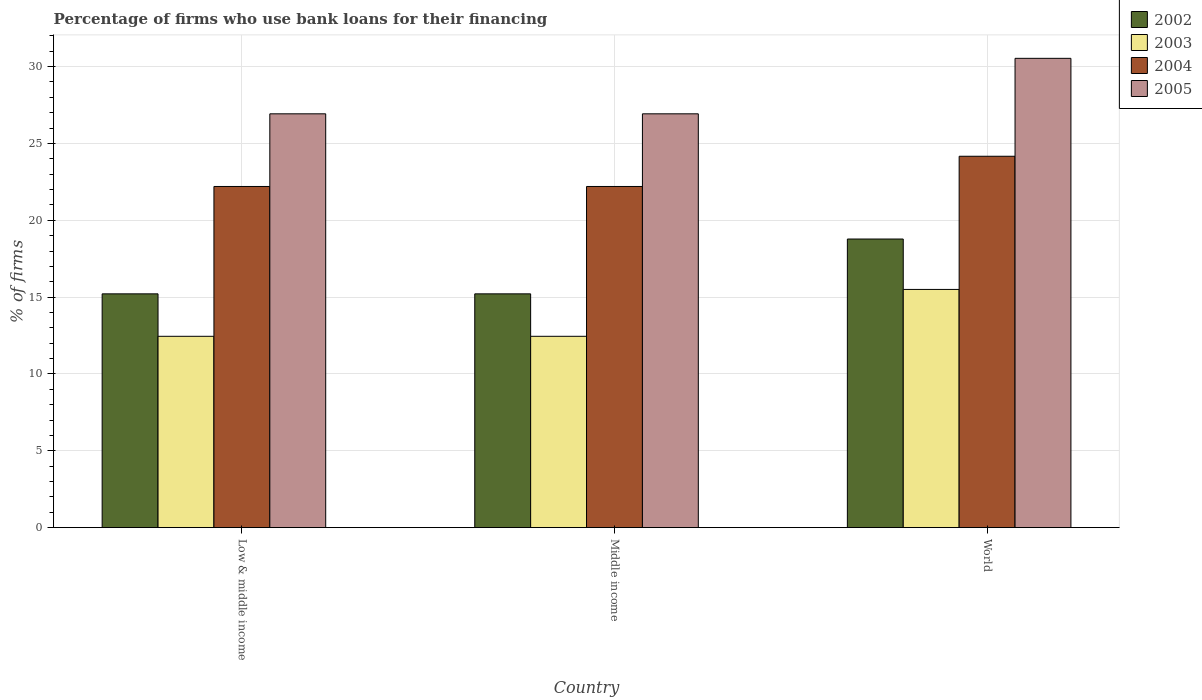How many different coloured bars are there?
Offer a very short reply. 4. Are the number of bars per tick equal to the number of legend labels?
Your answer should be very brief. Yes. Are the number of bars on each tick of the X-axis equal?
Ensure brevity in your answer.  Yes. What is the label of the 2nd group of bars from the left?
Offer a very short reply. Middle income. What is the percentage of firms who use bank loans for their financing in 2005 in Low & middle income?
Your answer should be compact. 26.93. Across all countries, what is the maximum percentage of firms who use bank loans for their financing in 2002?
Ensure brevity in your answer.  18.78. Across all countries, what is the minimum percentage of firms who use bank loans for their financing in 2004?
Keep it short and to the point. 22.2. In which country was the percentage of firms who use bank loans for their financing in 2005 maximum?
Offer a very short reply. World. In which country was the percentage of firms who use bank loans for their financing in 2005 minimum?
Ensure brevity in your answer.  Low & middle income. What is the total percentage of firms who use bank loans for their financing in 2004 in the graph?
Your answer should be compact. 68.57. What is the difference between the percentage of firms who use bank loans for their financing in 2004 in Low & middle income and that in World?
Offer a terse response. -1.97. What is the difference between the percentage of firms who use bank loans for their financing in 2002 in Low & middle income and the percentage of firms who use bank loans for their financing in 2003 in World?
Your answer should be compact. -0.29. What is the average percentage of firms who use bank loans for their financing in 2002 per country?
Give a very brief answer. 16.4. What is the difference between the percentage of firms who use bank loans for their financing of/in 2004 and percentage of firms who use bank loans for their financing of/in 2003 in World?
Ensure brevity in your answer.  8.67. In how many countries, is the percentage of firms who use bank loans for their financing in 2004 greater than 20 %?
Your answer should be compact. 3. What is the ratio of the percentage of firms who use bank loans for their financing in 2002 in Middle income to that in World?
Your answer should be very brief. 0.81. Is the difference between the percentage of firms who use bank loans for their financing in 2004 in Low & middle income and World greater than the difference between the percentage of firms who use bank loans for their financing in 2003 in Low & middle income and World?
Offer a terse response. Yes. What is the difference between the highest and the second highest percentage of firms who use bank loans for their financing in 2004?
Your answer should be very brief. 1.97. What is the difference between the highest and the lowest percentage of firms who use bank loans for their financing in 2004?
Offer a very short reply. 1.97. In how many countries, is the percentage of firms who use bank loans for their financing in 2003 greater than the average percentage of firms who use bank loans for their financing in 2003 taken over all countries?
Provide a short and direct response. 1. Is the sum of the percentage of firms who use bank loans for their financing in 2002 in Middle income and World greater than the maximum percentage of firms who use bank loans for their financing in 2003 across all countries?
Ensure brevity in your answer.  Yes. Is it the case that in every country, the sum of the percentage of firms who use bank loans for their financing in 2002 and percentage of firms who use bank loans for their financing in 2003 is greater than the sum of percentage of firms who use bank loans for their financing in 2005 and percentage of firms who use bank loans for their financing in 2004?
Your response must be concise. No. What does the 4th bar from the right in Middle income represents?
Ensure brevity in your answer.  2002. How many bars are there?
Your response must be concise. 12. What is the difference between two consecutive major ticks on the Y-axis?
Provide a succinct answer. 5. Are the values on the major ticks of Y-axis written in scientific E-notation?
Your response must be concise. No. Does the graph contain grids?
Your response must be concise. Yes. Where does the legend appear in the graph?
Offer a terse response. Top right. How many legend labels are there?
Your answer should be compact. 4. How are the legend labels stacked?
Give a very brief answer. Vertical. What is the title of the graph?
Make the answer very short. Percentage of firms who use bank loans for their financing. Does "1993" appear as one of the legend labels in the graph?
Your answer should be compact. No. What is the label or title of the Y-axis?
Give a very brief answer. % of firms. What is the % of firms in 2002 in Low & middle income?
Your answer should be very brief. 15.21. What is the % of firms in 2003 in Low & middle income?
Make the answer very short. 12.45. What is the % of firms in 2004 in Low & middle income?
Provide a succinct answer. 22.2. What is the % of firms of 2005 in Low & middle income?
Provide a short and direct response. 26.93. What is the % of firms in 2002 in Middle income?
Your response must be concise. 15.21. What is the % of firms of 2003 in Middle income?
Make the answer very short. 12.45. What is the % of firms of 2004 in Middle income?
Offer a very short reply. 22.2. What is the % of firms of 2005 in Middle income?
Your answer should be very brief. 26.93. What is the % of firms in 2002 in World?
Provide a succinct answer. 18.78. What is the % of firms of 2003 in World?
Provide a short and direct response. 15.5. What is the % of firms of 2004 in World?
Your answer should be very brief. 24.17. What is the % of firms in 2005 in World?
Make the answer very short. 30.54. Across all countries, what is the maximum % of firms of 2002?
Ensure brevity in your answer.  18.78. Across all countries, what is the maximum % of firms of 2003?
Offer a very short reply. 15.5. Across all countries, what is the maximum % of firms of 2004?
Make the answer very short. 24.17. Across all countries, what is the maximum % of firms in 2005?
Make the answer very short. 30.54. Across all countries, what is the minimum % of firms in 2002?
Offer a terse response. 15.21. Across all countries, what is the minimum % of firms of 2003?
Give a very brief answer. 12.45. Across all countries, what is the minimum % of firms in 2004?
Your answer should be compact. 22.2. Across all countries, what is the minimum % of firms of 2005?
Offer a very short reply. 26.93. What is the total % of firms of 2002 in the graph?
Your response must be concise. 49.21. What is the total % of firms in 2003 in the graph?
Provide a succinct answer. 40.4. What is the total % of firms of 2004 in the graph?
Your response must be concise. 68.57. What is the total % of firms of 2005 in the graph?
Give a very brief answer. 84.39. What is the difference between the % of firms of 2004 in Low & middle income and that in Middle income?
Your answer should be compact. 0. What is the difference between the % of firms of 2002 in Low & middle income and that in World?
Make the answer very short. -3.57. What is the difference between the % of firms of 2003 in Low & middle income and that in World?
Your response must be concise. -3.05. What is the difference between the % of firms of 2004 in Low & middle income and that in World?
Make the answer very short. -1.97. What is the difference between the % of firms in 2005 in Low & middle income and that in World?
Provide a succinct answer. -3.61. What is the difference between the % of firms of 2002 in Middle income and that in World?
Your answer should be very brief. -3.57. What is the difference between the % of firms of 2003 in Middle income and that in World?
Keep it short and to the point. -3.05. What is the difference between the % of firms in 2004 in Middle income and that in World?
Offer a terse response. -1.97. What is the difference between the % of firms in 2005 in Middle income and that in World?
Make the answer very short. -3.61. What is the difference between the % of firms in 2002 in Low & middle income and the % of firms in 2003 in Middle income?
Give a very brief answer. 2.76. What is the difference between the % of firms in 2002 in Low & middle income and the % of firms in 2004 in Middle income?
Give a very brief answer. -6.99. What is the difference between the % of firms in 2002 in Low & middle income and the % of firms in 2005 in Middle income?
Provide a succinct answer. -11.72. What is the difference between the % of firms in 2003 in Low & middle income and the % of firms in 2004 in Middle income?
Give a very brief answer. -9.75. What is the difference between the % of firms of 2003 in Low & middle income and the % of firms of 2005 in Middle income?
Your answer should be compact. -14.48. What is the difference between the % of firms of 2004 in Low & middle income and the % of firms of 2005 in Middle income?
Your response must be concise. -4.73. What is the difference between the % of firms of 2002 in Low & middle income and the % of firms of 2003 in World?
Ensure brevity in your answer.  -0.29. What is the difference between the % of firms in 2002 in Low & middle income and the % of firms in 2004 in World?
Your answer should be very brief. -8.95. What is the difference between the % of firms of 2002 in Low & middle income and the % of firms of 2005 in World?
Your response must be concise. -15.33. What is the difference between the % of firms of 2003 in Low & middle income and the % of firms of 2004 in World?
Offer a very short reply. -11.72. What is the difference between the % of firms of 2003 in Low & middle income and the % of firms of 2005 in World?
Ensure brevity in your answer.  -18.09. What is the difference between the % of firms of 2004 in Low & middle income and the % of firms of 2005 in World?
Ensure brevity in your answer.  -8.34. What is the difference between the % of firms in 2002 in Middle income and the % of firms in 2003 in World?
Provide a succinct answer. -0.29. What is the difference between the % of firms in 2002 in Middle income and the % of firms in 2004 in World?
Your response must be concise. -8.95. What is the difference between the % of firms in 2002 in Middle income and the % of firms in 2005 in World?
Offer a very short reply. -15.33. What is the difference between the % of firms of 2003 in Middle income and the % of firms of 2004 in World?
Your answer should be very brief. -11.72. What is the difference between the % of firms in 2003 in Middle income and the % of firms in 2005 in World?
Your answer should be compact. -18.09. What is the difference between the % of firms in 2004 in Middle income and the % of firms in 2005 in World?
Your response must be concise. -8.34. What is the average % of firms of 2002 per country?
Provide a short and direct response. 16.4. What is the average % of firms in 2003 per country?
Your answer should be compact. 13.47. What is the average % of firms in 2004 per country?
Provide a succinct answer. 22.86. What is the average % of firms in 2005 per country?
Your response must be concise. 28.13. What is the difference between the % of firms in 2002 and % of firms in 2003 in Low & middle income?
Keep it short and to the point. 2.76. What is the difference between the % of firms of 2002 and % of firms of 2004 in Low & middle income?
Ensure brevity in your answer.  -6.99. What is the difference between the % of firms in 2002 and % of firms in 2005 in Low & middle income?
Ensure brevity in your answer.  -11.72. What is the difference between the % of firms in 2003 and % of firms in 2004 in Low & middle income?
Offer a terse response. -9.75. What is the difference between the % of firms of 2003 and % of firms of 2005 in Low & middle income?
Provide a short and direct response. -14.48. What is the difference between the % of firms of 2004 and % of firms of 2005 in Low & middle income?
Provide a succinct answer. -4.73. What is the difference between the % of firms in 2002 and % of firms in 2003 in Middle income?
Provide a succinct answer. 2.76. What is the difference between the % of firms of 2002 and % of firms of 2004 in Middle income?
Your response must be concise. -6.99. What is the difference between the % of firms of 2002 and % of firms of 2005 in Middle income?
Your answer should be very brief. -11.72. What is the difference between the % of firms of 2003 and % of firms of 2004 in Middle income?
Provide a succinct answer. -9.75. What is the difference between the % of firms in 2003 and % of firms in 2005 in Middle income?
Give a very brief answer. -14.48. What is the difference between the % of firms in 2004 and % of firms in 2005 in Middle income?
Offer a terse response. -4.73. What is the difference between the % of firms of 2002 and % of firms of 2003 in World?
Your response must be concise. 3.28. What is the difference between the % of firms in 2002 and % of firms in 2004 in World?
Give a very brief answer. -5.39. What is the difference between the % of firms of 2002 and % of firms of 2005 in World?
Your answer should be compact. -11.76. What is the difference between the % of firms in 2003 and % of firms in 2004 in World?
Keep it short and to the point. -8.67. What is the difference between the % of firms of 2003 and % of firms of 2005 in World?
Your answer should be compact. -15.04. What is the difference between the % of firms in 2004 and % of firms in 2005 in World?
Your answer should be very brief. -6.37. What is the ratio of the % of firms in 2003 in Low & middle income to that in Middle income?
Keep it short and to the point. 1. What is the ratio of the % of firms in 2002 in Low & middle income to that in World?
Your response must be concise. 0.81. What is the ratio of the % of firms in 2003 in Low & middle income to that in World?
Ensure brevity in your answer.  0.8. What is the ratio of the % of firms of 2004 in Low & middle income to that in World?
Provide a succinct answer. 0.92. What is the ratio of the % of firms of 2005 in Low & middle income to that in World?
Provide a succinct answer. 0.88. What is the ratio of the % of firms of 2002 in Middle income to that in World?
Provide a succinct answer. 0.81. What is the ratio of the % of firms in 2003 in Middle income to that in World?
Keep it short and to the point. 0.8. What is the ratio of the % of firms in 2004 in Middle income to that in World?
Offer a terse response. 0.92. What is the ratio of the % of firms of 2005 in Middle income to that in World?
Make the answer very short. 0.88. What is the difference between the highest and the second highest % of firms in 2002?
Give a very brief answer. 3.57. What is the difference between the highest and the second highest % of firms of 2003?
Your answer should be very brief. 3.05. What is the difference between the highest and the second highest % of firms of 2004?
Provide a succinct answer. 1.97. What is the difference between the highest and the second highest % of firms of 2005?
Give a very brief answer. 3.61. What is the difference between the highest and the lowest % of firms in 2002?
Your response must be concise. 3.57. What is the difference between the highest and the lowest % of firms in 2003?
Offer a very short reply. 3.05. What is the difference between the highest and the lowest % of firms of 2004?
Make the answer very short. 1.97. What is the difference between the highest and the lowest % of firms in 2005?
Ensure brevity in your answer.  3.61. 